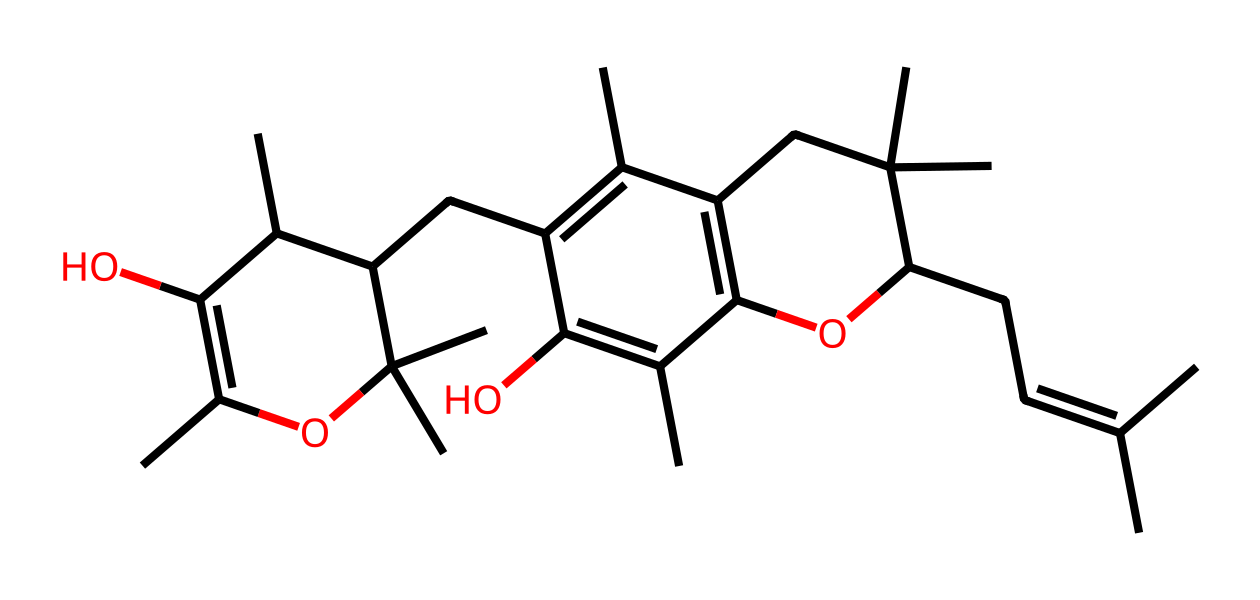What is the molecular formula of vitamin E represented by this SMILES? To determine the molecular formula, count the number of each type of atom present in the SMILES. By analyzing the structure, you can see there are 29 carbon atoms, 50 hydrogen atoms, and 2 oxygen atoms, giving the formula C29H50O2.
Answer: C29H50O2 How many rings are present in the structure of vitamin E? Looking at the chemical structure, there are two distinct cyclic parts formed by carbon atoms. Each of these cyclic structures counts as one ring, resulting in a total of two rings.
Answer: 2 What specific role do the hydroxyl groups (-OH) play in vitamin E's structure? The hydroxyl groups in vitamin E donate hydrogen bonds, contributing to its solubility in lipids and enhancing its antioxidant activity by neutralizing free radicals.
Answer: antioxidant activity What is the total number of double bonds in the molecular structure? By inspecting the carbon backbone in the chemical structure, count the number of double bonds. There are 4 double bonds connecting carbon atoms in various parts of the molecule.
Answer: 4 What type of isomerism is exhibited by vitamin E? Vitamin E can exhibit geometric isomerism due to the presence of double bonds that create the possibility of cis and trans orientations in the molecule.
Answer: geometric isomerism Which substructure contributes most to the antioxidant properties of vitamin E? The presence of the aromatic ring in the vitamin E structure is crucial as it stabilizes free radicals, effectively playing a significant role in its antioxidant capabilities.
Answer: aromatic ring 